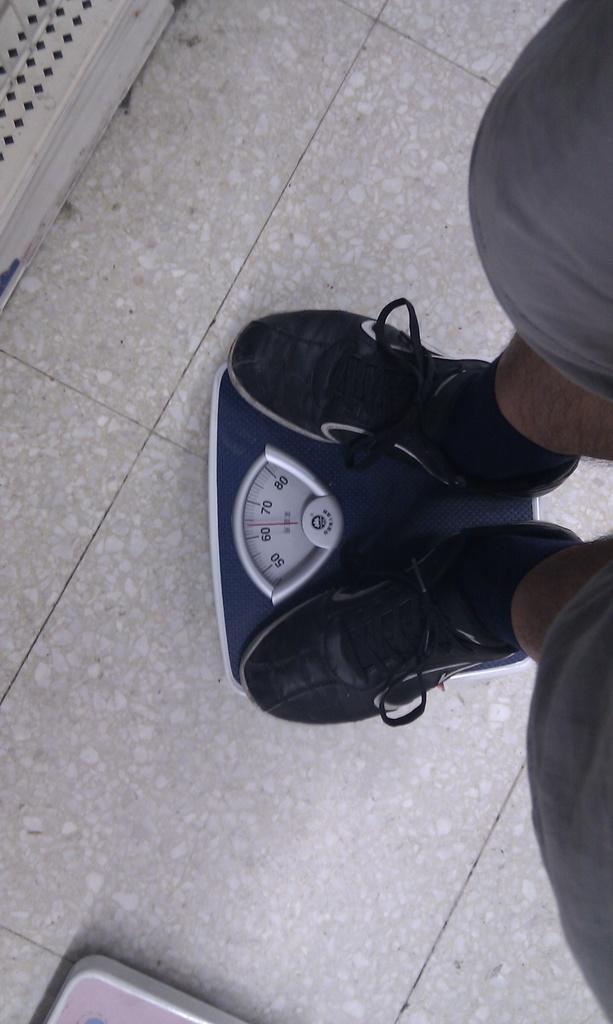How would you summarize this image in a sentence or two? In this image I can see a person standing on the weighing machine. I can also see black color shoes and the floor is in cream color. 